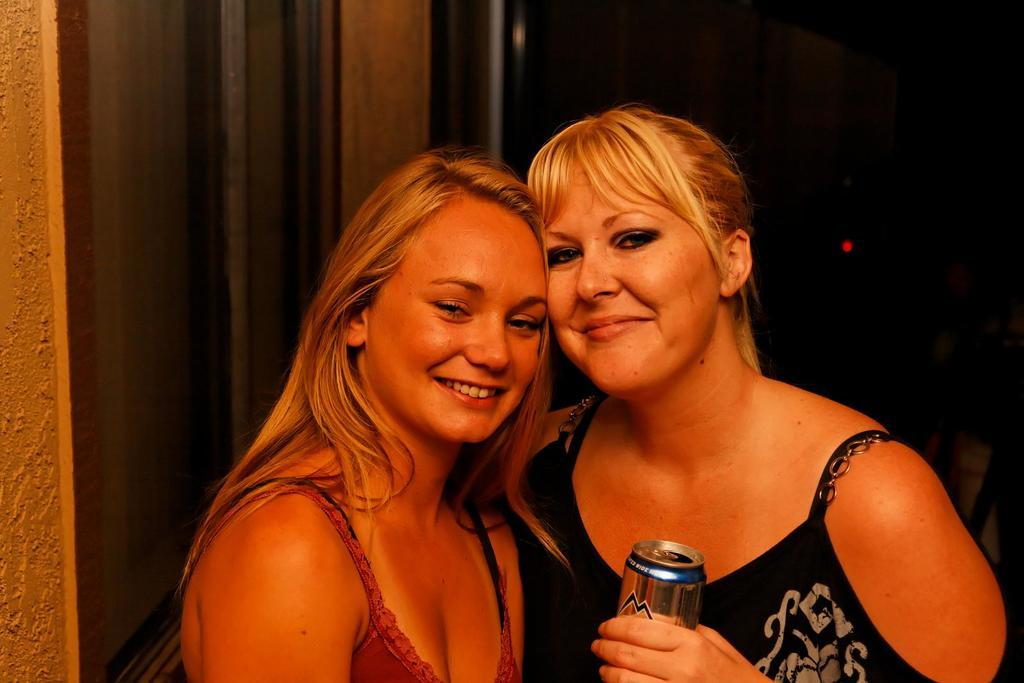How many women are in the image? There are two women in the image. What is the woman on the right wearing? The woman on the right is wearing a black dress. What is the woman on the right holding? The woman on the right is holding a tin. What can be seen in the background of the image? There is a door visible in the background of the image. How would you describe the lighting in the image? The background of the image is dark. What type of sand can be seen on the seashore in the image? There is no seashore or sand present in the image; it features two women and a door in a dark background. 